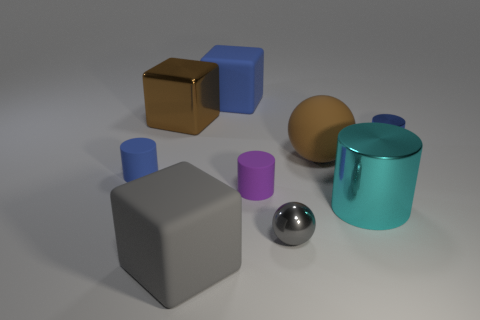Subtract all brown blocks. Subtract all brown spheres. How many blocks are left? 2 Add 1 large blue rubber spheres. How many objects exist? 10 Subtract all cubes. How many objects are left? 6 Add 8 brown blocks. How many brown blocks are left? 9 Add 9 tiny red cylinders. How many tiny red cylinders exist? 9 Subtract 0 red cylinders. How many objects are left? 9 Subtract all large gray cubes. Subtract all brown blocks. How many objects are left? 7 